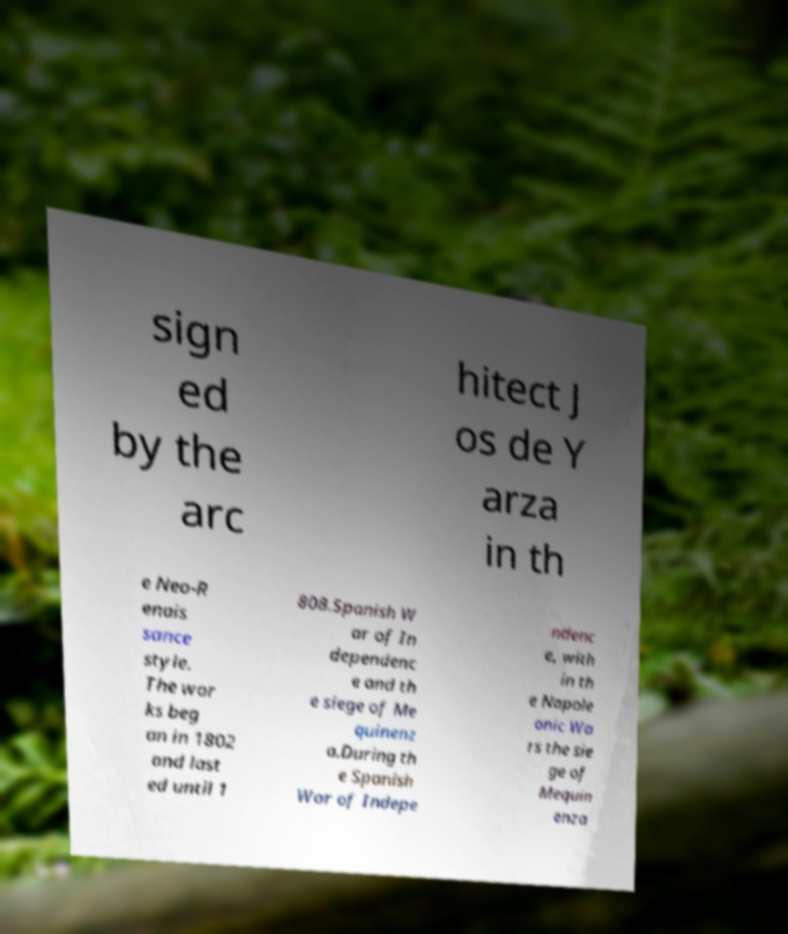Could you extract and type out the text from this image? sign ed by the arc hitect J os de Y arza in th e Neo-R enais sance style. The wor ks beg an in 1802 and last ed until 1 808.Spanish W ar of In dependenc e and th e siege of Me quinenz a.During th e Spanish War of Indepe ndenc e, with in th e Napole onic Wa rs the sie ge of Mequin enza 